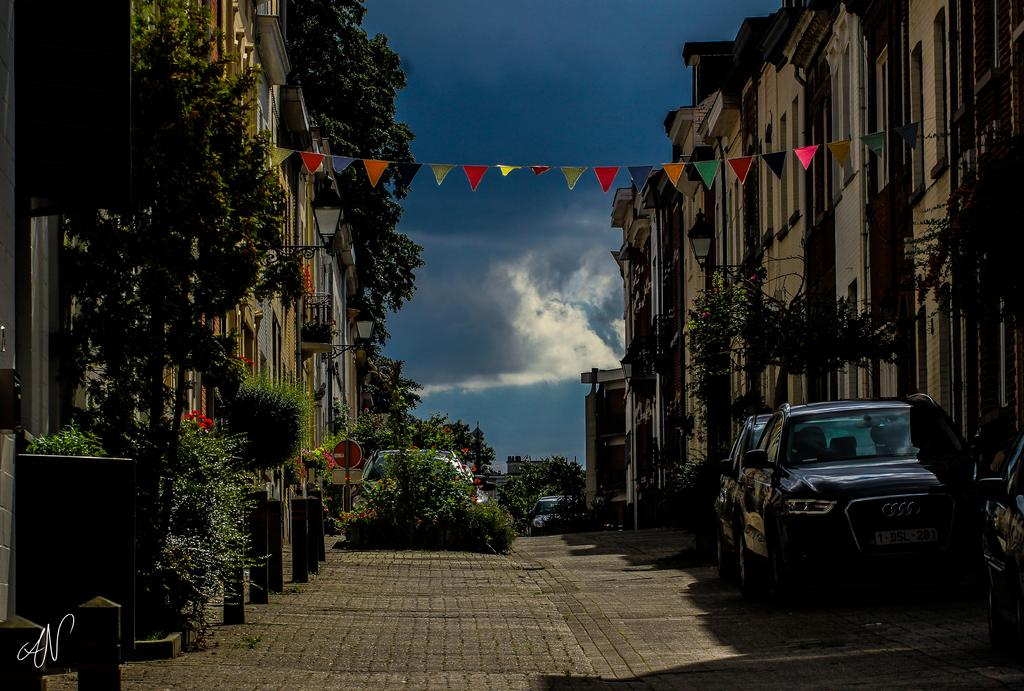What type of structures can be seen in the image? There are buildings in the image. What type of natural elements are present in the image? There are trees and plants in the image. What type of man-made objects can be seen in the image? There are vehicles in the image. How many boys are controlling the vehicles in the image? There are no boys present in the image, and therefore no one is controlling the vehicles. What type of thumb can be seen interacting with the plants in the image? There is no thumb present in the image; only the buildings, trees, plants, and vehicles are visible. 